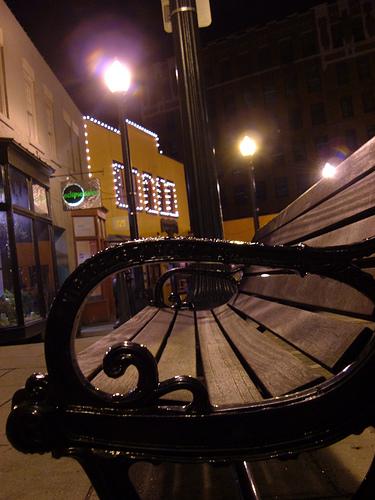How many lamps are lit up?
Give a very brief answer. 3. What surrounds the roof and windows of the yellow building?
Answer briefly. Lights. What is the bench made of?
Answer briefly. Wood. 